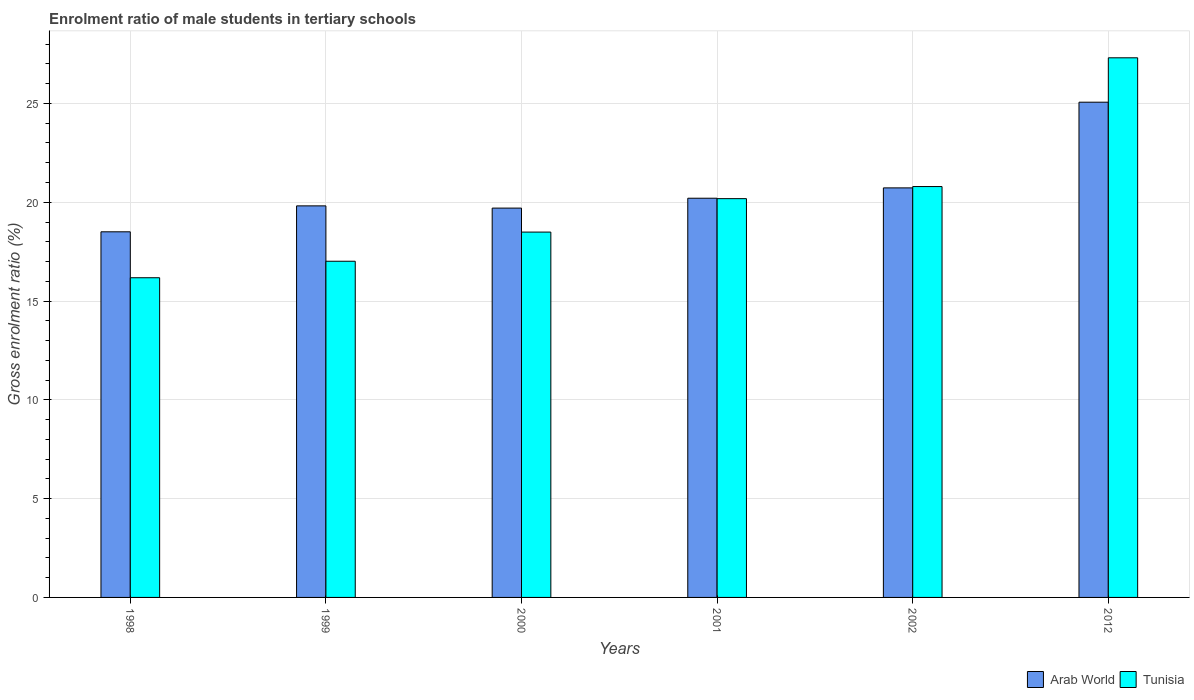How many groups of bars are there?
Provide a succinct answer. 6. Are the number of bars on each tick of the X-axis equal?
Provide a short and direct response. Yes. What is the label of the 3rd group of bars from the left?
Offer a very short reply. 2000. What is the enrolment ratio of male students in tertiary schools in Tunisia in 1998?
Offer a terse response. 16.18. Across all years, what is the maximum enrolment ratio of male students in tertiary schools in Arab World?
Keep it short and to the point. 25.06. Across all years, what is the minimum enrolment ratio of male students in tertiary schools in Tunisia?
Ensure brevity in your answer.  16.18. What is the total enrolment ratio of male students in tertiary schools in Tunisia in the graph?
Your answer should be very brief. 119.97. What is the difference between the enrolment ratio of male students in tertiary schools in Tunisia in 2000 and that in 2002?
Provide a short and direct response. -2.3. What is the difference between the enrolment ratio of male students in tertiary schools in Arab World in 2001 and the enrolment ratio of male students in tertiary schools in Tunisia in 2012?
Your answer should be compact. -7.11. What is the average enrolment ratio of male students in tertiary schools in Arab World per year?
Your response must be concise. 20.67. In the year 2000, what is the difference between the enrolment ratio of male students in tertiary schools in Arab World and enrolment ratio of male students in tertiary schools in Tunisia?
Make the answer very short. 1.21. What is the ratio of the enrolment ratio of male students in tertiary schools in Tunisia in 1999 to that in 2012?
Offer a very short reply. 0.62. Is the enrolment ratio of male students in tertiary schools in Arab World in 1999 less than that in 2012?
Offer a very short reply. Yes. What is the difference between the highest and the second highest enrolment ratio of male students in tertiary schools in Tunisia?
Your answer should be compact. 6.52. What is the difference between the highest and the lowest enrolment ratio of male students in tertiary schools in Arab World?
Offer a very short reply. 6.56. Is the sum of the enrolment ratio of male students in tertiary schools in Tunisia in 1998 and 1999 greater than the maximum enrolment ratio of male students in tertiary schools in Arab World across all years?
Keep it short and to the point. Yes. What does the 1st bar from the left in 1998 represents?
Your answer should be compact. Arab World. What does the 1st bar from the right in 2000 represents?
Ensure brevity in your answer.  Tunisia. How many bars are there?
Keep it short and to the point. 12. Are all the bars in the graph horizontal?
Make the answer very short. No. How many years are there in the graph?
Give a very brief answer. 6. Are the values on the major ticks of Y-axis written in scientific E-notation?
Your response must be concise. No. Does the graph contain any zero values?
Offer a terse response. No. How many legend labels are there?
Provide a succinct answer. 2. How are the legend labels stacked?
Give a very brief answer. Horizontal. What is the title of the graph?
Your answer should be compact. Enrolment ratio of male students in tertiary schools. Does "Nepal" appear as one of the legend labels in the graph?
Your answer should be compact. No. What is the Gross enrolment ratio (%) of Arab World in 1998?
Offer a terse response. 18.5. What is the Gross enrolment ratio (%) in Tunisia in 1998?
Your response must be concise. 16.18. What is the Gross enrolment ratio (%) in Arab World in 1999?
Offer a very short reply. 19.82. What is the Gross enrolment ratio (%) of Tunisia in 1999?
Provide a short and direct response. 17.01. What is the Gross enrolment ratio (%) of Arab World in 2000?
Provide a short and direct response. 19.7. What is the Gross enrolment ratio (%) of Tunisia in 2000?
Your answer should be compact. 18.49. What is the Gross enrolment ratio (%) of Arab World in 2001?
Keep it short and to the point. 20.2. What is the Gross enrolment ratio (%) of Tunisia in 2001?
Give a very brief answer. 20.18. What is the Gross enrolment ratio (%) in Arab World in 2002?
Make the answer very short. 20.73. What is the Gross enrolment ratio (%) in Tunisia in 2002?
Your answer should be very brief. 20.79. What is the Gross enrolment ratio (%) in Arab World in 2012?
Your answer should be compact. 25.06. What is the Gross enrolment ratio (%) of Tunisia in 2012?
Your answer should be compact. 27.31. Across all years, what is the maximum Gross enrolment ratio (%) of Arab World?
Your answer should be compact. 25.06. Across all years, what is the maximum Gross enrolment ratio (%) in Tunisia?
Provide a short and direct response. 27.31. Across all years, what is the minimum Gross enrolment ratio (%) of Arab World?
Provide a succinct answer. 18.5. Across all years, what is the minimum Gross enrolment ratio (%) of Tunisia?
Provide a short and direct response. 16.18. What is the total Gross enrolment ratio (%) in Arab World in the graph?
Offer a very short reply. 124.02. What is the total Gross enrolment ratio (%) in Tunisia in the graph?
Keep it short and to the point. 119.97. What is the difference between the Gross enrolment ratio (%) of Arab World in 1998 and that in 1999?
Provide a short and direct response. -1.31. What is the difference between the Gross enrolment ratio (%) of Tunisia in 1998 and that in 1999?
Your answer should be very brief. -0.84. What is the difference between the Gross enrolment ratio (%) of Arab World in 1998 and that in 2000?
Provide a succinct answer. -1.2. What is the difference between the Gross enrolment ratio (%) of Tunisia in 1998 and that in 2000?
Offer a terse response. -2.31. What is the difference between the Gross enrolment ratio (%) in Arab World in 1998 and that in 2001?
Make the answer very short. -1.7. What is the difference between the Gross enrolment ratio (%) in Tunisia in 1998 and that in 2001?
Your answer should be compact. -4. What is the difference between the Gross enrolment ratio (%) in Arab World in 1998 and that in 2002?
Ensure brevity in your answer.  -2.22. What is the difference between the Gross enrolment ratio (%) in Tunisia in 1998 and that in 2002?
Your response must be concise. -4.62. What is the difference between the Gross enrolment ratio (%) in Arab World in 1998 and that in 2012?
Your answer should be very brief. -6.56. What is the difference between the Gross enrolment ratio (%) of Tunisia in 1998 and that in 2012?
Your answer should be very brief. -11.13. What is the difference between the Gross enrolment ratio (%) in Arab World in 1999 and that in 2000?
Your answer should be very brief. 0.11. What is the difference between the Gross enrolment ratio (%) in Tunisia in 1999 and that in 2000?
Make the answer very short. -1.48. What is the difference between the Gross enrolment ratio (%) in Arab World in 1999 and that in 2001?
Give a very brief answer. -0.39. What is the difference between the Gross enrolment ratio (%) of Tunisia in 1999 and that in 2001?
Your answer should be compact. -3.17. What is the difference between the Gross enrolment ratio (%) in Arab World in 1999 and that in 2002?
Make the answer very short. -0.91. What is the difference between the Gross enrolment ratio (%) of Tunisia in 1999 and that in 2002?
Make the answer very short. -3.78. What is the difference between the Gross enrolment ratio (%) of Arab World in 1999 and that in 2012?
Provide a succinct answer. -5.25. What is the difference between the Gross enrolment ratio (%) in Tunisia in 1999 and that in 2012?
Give a very brief answer. -10.3. What is the difference between the Gross enrolment ratio (%) of Arab World in 2000 and that in 2001?
Provide a succinct answer. -0.5. What is the difference between the Gross enrolment ratio (%) in Tunisia in 2000 and that in 2001?
Make the answer very short. -1.69. What is the difference between the Gross enrolment ratio (%) of Arab World in 2000 and that in 2002?
Keep it short and to the point. -1.02. What is the difference between the Gross enrolment ratio (%) in Tunisia in 2000 and that in 2002?
Offer a very short reply. -2.3. What is the difference between the Gross enrolment ratio (%) of Arab World in 2000 and that in 2012?
Ensure brevity in your answer.  -5.36. What is the difference between the Gross enrolment ratio (%) of Tunisia in 2000 and that in 2012?
Make the answer very short. -8.82. What is the difference between the Gross enrolment ratio (%) in Arab World in 2001 and that in 2002?
Give a very brief answer. -0.52. What is the difference between the Gross enrolment ratio (%) of Tunisia in 2001 and that in 2002?
Make the answer very short. -0.61. What is the difference between the Gross enrolment ratio (%) of Arab World in 2001 and that in 2012?
Give a very brief answer. -4.86. What is the difference between the Gross enrolment ratio (%) in Tunisia in 2001 and that in 2012?
Offer a terse response. -7.13. What is the difference between the Gross enrolment ratio (%) in Arab World in 2002 and that in 2012?
Provide a short and direct response. -4.34. What is the difference between the Gross enrolment ratio (%) of Tunisia in 2002 and that in 2012?
Offer a very short reply. -6.52. What is the difference between the Gross enrolment ratio (%) of Arab World in 1998 and the Gross enrolment ratio (%) of Tunisia in 1999?
Make the answer very short. 1.49. What is the difference between the Gross enrolment ratio (%) in Arab World in 1998 and the Gross enrolment ratio (%) in Tunisia in 2000?
Keep it short and to the point. 0.01. What is the difference between the Gross enrolment ratio (%) of Arab World in 1998 and the Gross enrolment ratio (%) of Tunisia in 2001?
Your response must be concise. -1.68. What is the difference between the Gross enrolment ratio (%) in Arab World in 1998 and the Gross enrolment ratio (%) in Tunisia in 2002?
Offer a terse response. -2.29. What is the difference between the Gross enrolment ratio (%) in Arab World in 1998 and the Gross enrolment ratio (%) in Tunisia in 2012?
Your answer should be very brief. -8.81. What is the difference between the Gross enrolment ratio (%) of Arab World in 1999 and the Gross enrolment ratio (%) of Tunisia in 2000?
Provide a succinct answer. 1.33. What is the difference between the Gross enrolment ratio (%) of Arab World in 1999 and the Gross enrolment ratio (%) of Tunisia in 2001?
Provide a succinct answer. -0.37. What is the difference between the Gross enrolment ratio (%) in Arab World in 1999 and the Gross enrolment ratio (%) in Tunisia in 2002?
Provide a short and direct response. -0.98. What is the difference between the Gross enrolment ratio (%) of Arab World in 1999 and the Gross enrolment ratio (%) of Tunisia in 2012?
Offer a terse response. -7.49. What is the difference between the Gross enrolment ratio (%) in Arab World in 2000 and the Gross enrolment ratio (%) in Tunisia in 2001?
Your answer should be very brief. -0.48. What is the difference between the Gross enrolment ratio (%) of Arab World in 2000 and the Gross enrolment ratio (%) of Tunisia in 2002?
Your answer should be compact. -1.09. What is the difference between the Gross enrolment ratio (%) of Arab World in 2000 and the Gross enrolment ratio (%) of Tunisia in 2012?
Keep it short and to the point. -7.61. What is the difference between the Gross enrolment ratio (%) in Arab World in 2001 and the Gross enrolment ratio (%) in Tunisia in 2002?
Keep it short and to the point. -0.59. What is the difference between the Gross enrolment ratio (%) in Arab World in 2001 and the Gross enrolment ratio (%) in Tunisia in 2012?
Your answer should be compact. -7.11. What is the difference between the Gross enrolment ratio (%) of Arab World in 2002 and the Gross enrolment ratio (%) of Tunisia in 2012?
Make the answer very short. -6.58. What is the average Gross enrolment ratio (%) of Arab World per year?
Your response must be concise. 20.67. What is the average Gross enrolment ratio (%) of Tunisia per year?
Make the answer very short. 20. In the year 1998, what is the difference between the Gross enrolment ratio (%) of Arab World and Gross enrolment ratio (%) of Tunisia?
Give a very brief answer. 2.33. In the year 1999, what is the difference between the Gross enrolment ratio (%) in Arab World and Gross enrolment ratio (%) in Tunisia?
Give a very brief answer. 2.8. In the year 2000, what is the difference between the Gross enrolment ratio (%) in Arab World and Gross enrolment ratio (%) in Tunisia?
Offer a very short reply. 1.21. In the year 2001, what is the difference between the Gross enrolment ratio (%) of Arab World and Gross enrolment ratio (%) of Tunisia?
Offer a very short reply. 0.02. In the year 2002, what is the difference between the Gross enrolment ratio (%) in Arab World and Gross enrolment ratio (%) in Tunisia?
Offer a very short reply. -0.07. In the year 2012, what is the difference between the Gross enrolment ratio (%) in Arab World and Gross enrolment ratio (%) in Tunisia?
Your answer should be very brief. -2.25. What is the ratio of the Gross enrolment ratio (%) in Arab World in 1998 to that in 1999?
Offer a very short reply. 0.93. What is the ratio of the Gross enrolment ratio (%) in Tunisia in 1998 to that in 1999?
Your answer should be compact. 0.95. What is the ratio of the Gross enrolment ratio (%) of Arab World in 1998 to that in 2000?
Provide a succinct answer. 0.94. What is the ratio of the Gross enrolment ratio (%) in Arab World in 1998 to that in 2001?
Keep it short and to the point. 0.92. What is the ratio of the Gross enrolment ratio (%) of Tunisia in 1998 to that in 2001?
Keep it short and to the point. 0.8. What is the ratio of the Gross enrolment ratio (%) in Arab World in 1998 to that in 2002?
Offer a very short reply. 0.89. What is the ratio of the Gross enrolment ratio (%) in Tunisia in 1998 to that in 2002?
Provide a short and direct response. 0.78. What is the ratio of the Gross enrolment ratio (%) in Arab World in 1998 to that in 2012?
Offer a very short reply. 0.74. What is the ratio of the Gross enrolment ratio (%) of Tunisia in 1998 to that in 2012?
Make the answer very short. 0.59. What is the ratio of the Gross enrolment ratio (%) of Arab World in 1999 to that in 2000?
Offer a terse response. 1.01. What is the ratio of the Gross enrolment ratio (%) in Tunisia in 1999 to that in 2000?
Provide a succinct answer. 0.92. What is the ratio of the Gross enrolment ratio (%) of Arab World in 1999 to that in 2001?
Ensure brevity in your answer.  0.98. What is the ratio of the Gross enrolment ratio (%) in Tunisia in 1999 to that in 2001?
Make the answer very short. 0.84. What is the ratio of the Gross enrolment ratio (%) of Arab World in 1999 to that in 2002?
Provide a succinct answer. 0.96. What is the ratio of the Gross enrolment ratio (%) in Tunisia in 1999 to that in 2002?
Offer a very short reply. 0.82. What is the ratio of the Gross enrolment ratio (%) of Arab World in 1999 to that in 2012?
Ensure brevity in your answer.  0.79. What is the ratio of the Gross enrolment ratio (%) of Tunisia in 1999 to that in 2012?
Keep it short and to the point. 0.62. What is the ratio of the Gross enrolment ratio (%) in Arab World in 2000 to that in 2001?
Give a very brief answer. 0.98. What is the ratio of the Gross enrolment ratio (%) of Tunisia in 2000 to that in 2001?
Give a very brief answer. 0.92. What is the ratio of the Gross enrolment ratio (%) in Arab World in 2000 to that in 2002?
Your answer should be compact. 0.95. What is the ratio of the Gross enrolment ratio (%) in Tunisia in 2000 to that in 2002?
Ensure brevity in your answer.  0.89. What is the ratio of the Gross enrolment ratio (%) in Arab World in 2000 to that in 2012?
Provide a short and direct response. 0.79. What is the ratio of the Gross enrolment ratio (%) of Tunisia in 2000 to that in 2012?
Your answer should be very brief. 0.68. What is the ratio of the Gross enrolment ratio (%) of Arab World in 2001 to that in 2002?
Ensure brevity in your answer.  0.97. What is the ratio of the Gross enrolment ratio (%) of Tunisia in 2001 to that in 2002?
Provide a succinct answer. 0.97. What is the ratio of the Gross enrolment ratio (%) of Arab World in 2001 to that in 2012?
Offer a very short reply. 0.81. What is the ratio of the Gross enrolment ratio (%) of Tunisia in 2001 to that in 2012?
Provide a short and direct response. 0.74. What is the ratio of the Gross enrolment ratio (%) of Arab World in 2002 to that in 2012?
Give a very brief answer. 0.83. What is the ratio of the Gross enrolment ratio (%) in Tunisia in 2002 to that in 2012?
Give a very brief answer. 0.76. What is the difference between the highest and the second highest Gross enrolment ratio (%) in Arab World?
Keep it short and to the point. 4.34. What is the difference between the highest and the second highest Gross enrolment ratio (%) in Tunisia?
Make the answer very short. 6.52. What is the difference between the highest and the lowest Gross enrolment ratio (%) in Arab World?
Provide a short and direct response. 6.56. What is the difference between the highest and the lowest Gross enrolment ratio (%) in Tunisia?
Give a very brief answer. 11.13. 